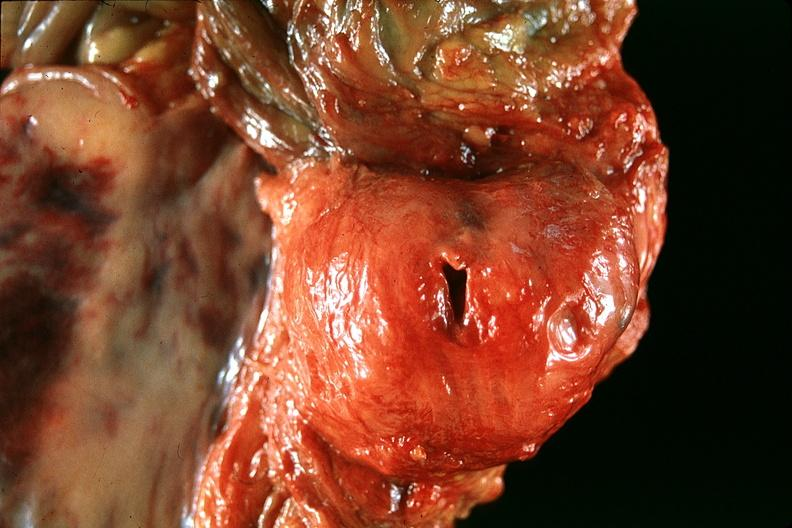what is present?
Answer the question using a single word or phrase. Urinary 